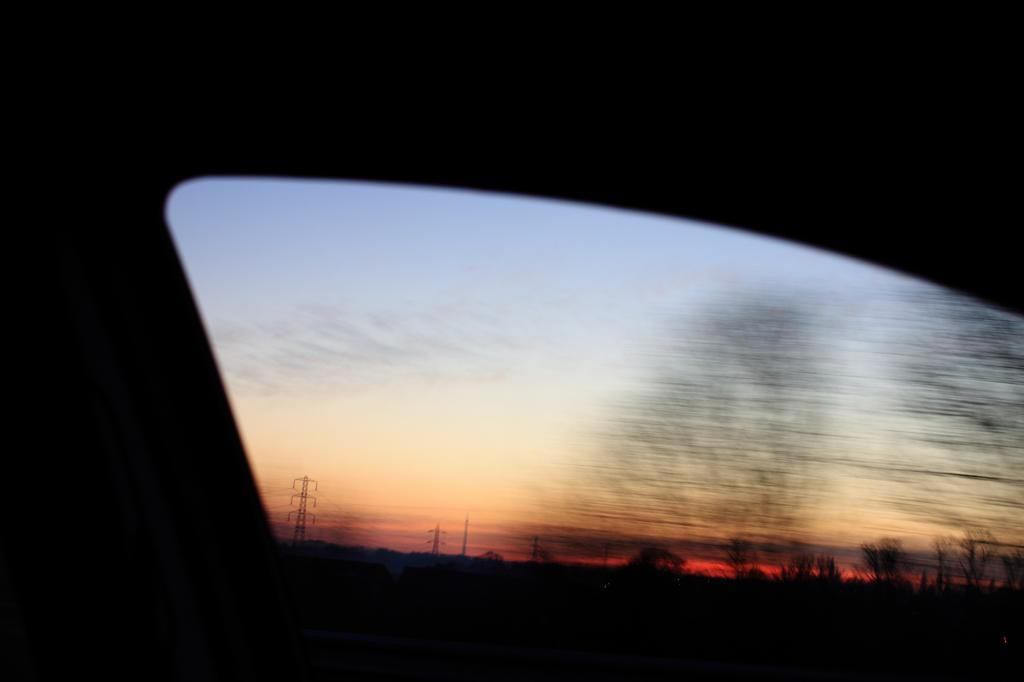How would you summarize this image in a sentence or two? In this image in front there is a glass window through which we can see towers, trees and sky. 